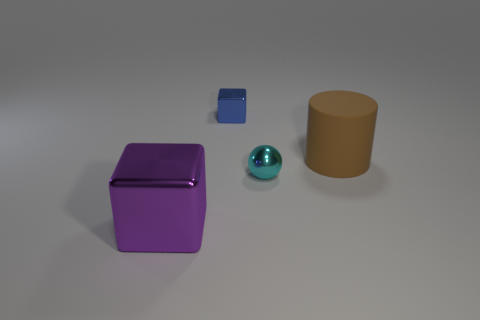There is a blue thing that is the same shape as the big purple thing; what material is it?
Keep it short and to the point. Metal. Are there any other things that are the same shape as the large brown object?
Offer a terse response. No. The small metal ball is what color?
Ensure brevity in your answer.  Cyan. There is a metallic cube behind the purple metal object; is its size the same as the shiny object that is to the right of the tiny block?
Keep it short and to the point. Yes. The other object that is the same shape as the small blue thing is what size?
Offer a very short reply. Large. Are there more metal objects in front of the tiny sphere than blue blocks right of the blue shiny thing?
Your response must be concise. Yes. What material is the thing that is both in front of the brown rubber cylinder and to the right of the tiny cube?
Give a very brief answer. Metal. What is the color of the other thing that is the same shape as the tiny blue object?
Give a very brief answer. Purple. The blue metal thing has what size?
Your answer should be very brief. Small. What is the color of the big thing that is in front of the tiny metallic thing that is in front of the brown cylinder?
Your answer should be very brief. Purple. 